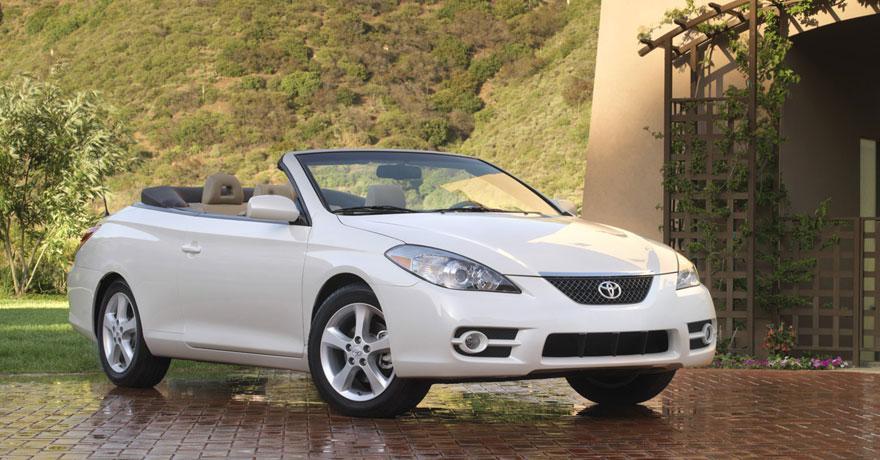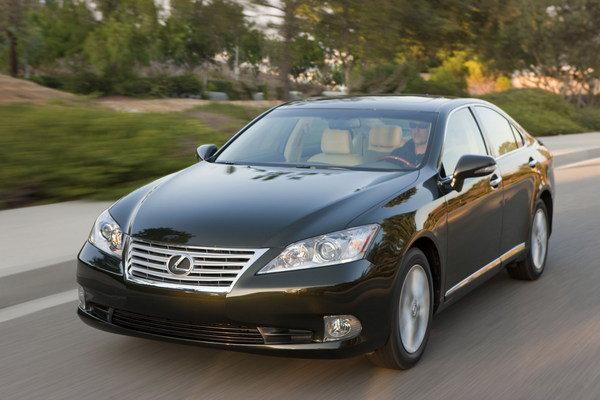The first image is the image on the left, the second image is the image on the right. Given the left and right images, does the statement "One car has a hard top and the other car is a topless convertible, and the cars in the left and right images appear to face each other." hold true? Answer yes or no. Yes. The first image is the image on the left, the second image is the image on the right. Given the left and right images, does the statement "One of the images features a white convertible car." hold true? Answer yes or no. Yes. 